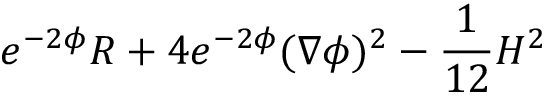<formula> <loc_0><loc_0><loc_500><loc_500>e ^ { - 2 \phi } R + 4 e ^ { - 2 \phi } ( \nabla \phi ) ^ { 2 } - { \frac { 1 } { 1 2 } } H ^ { 2 }</formula> 